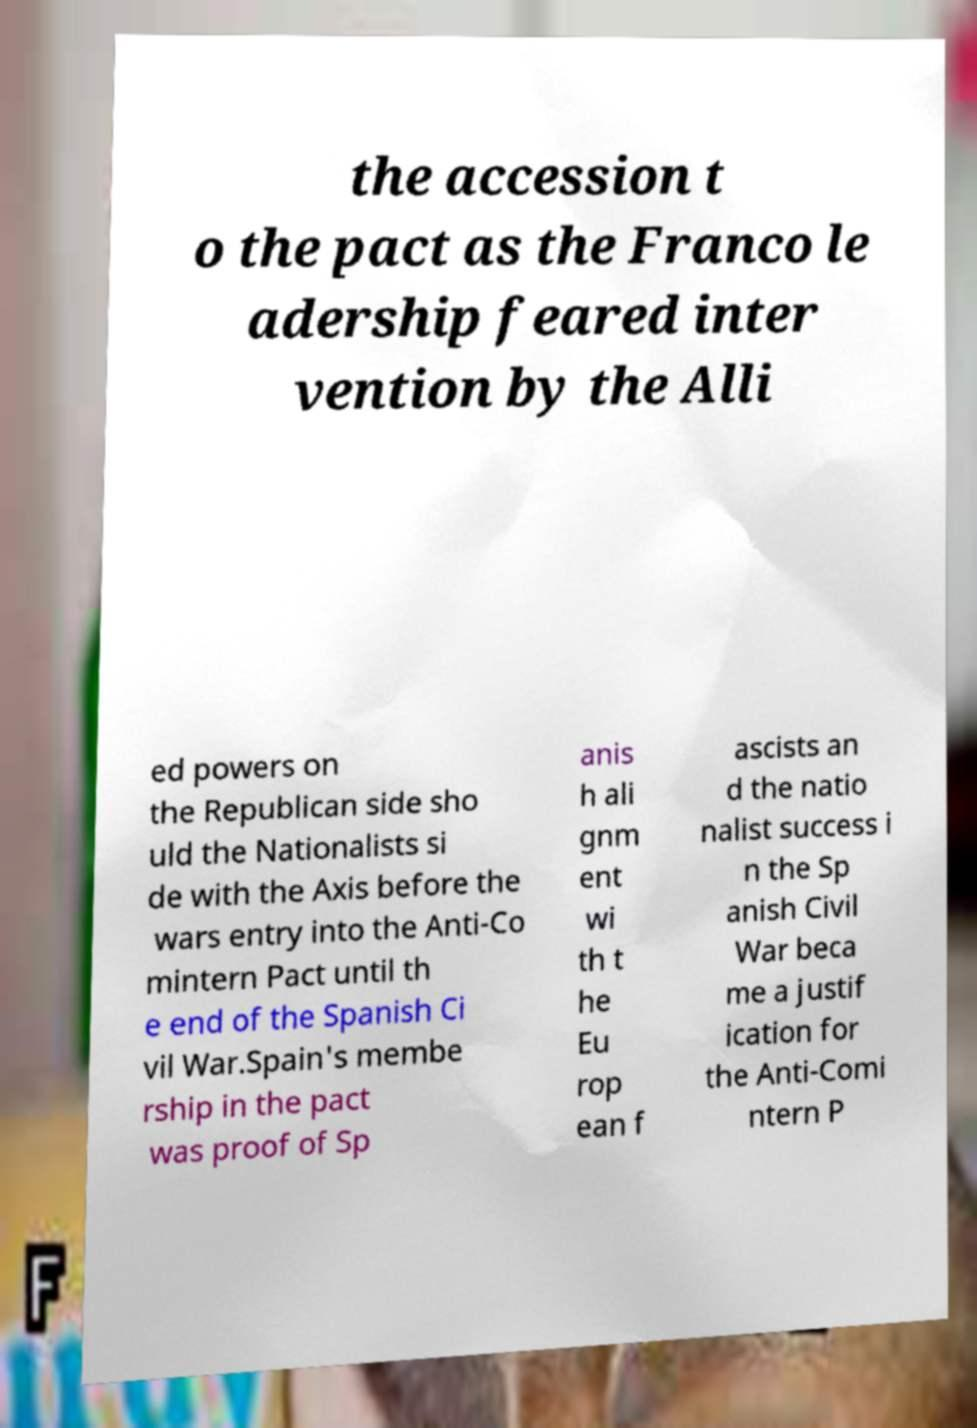Please read and relay the text visible in this image. What does it say? the accession t o the pact as the Franco le adership feared inter vention by the Alli ed powers on the Republican side sho uld the Nationalists si de with the Axis before the wars entry into the Anti-Co mintern Pact until th e end of the Spanish Ci vil War.Spain's membe rship in the pact was proof of Sp anis h ali gnm ent wi th t he Eu rop ean f ascists an d the natio nalist success i n the Sp anish Civil War beca me a justif ication for the Anti-Comi ntern P 